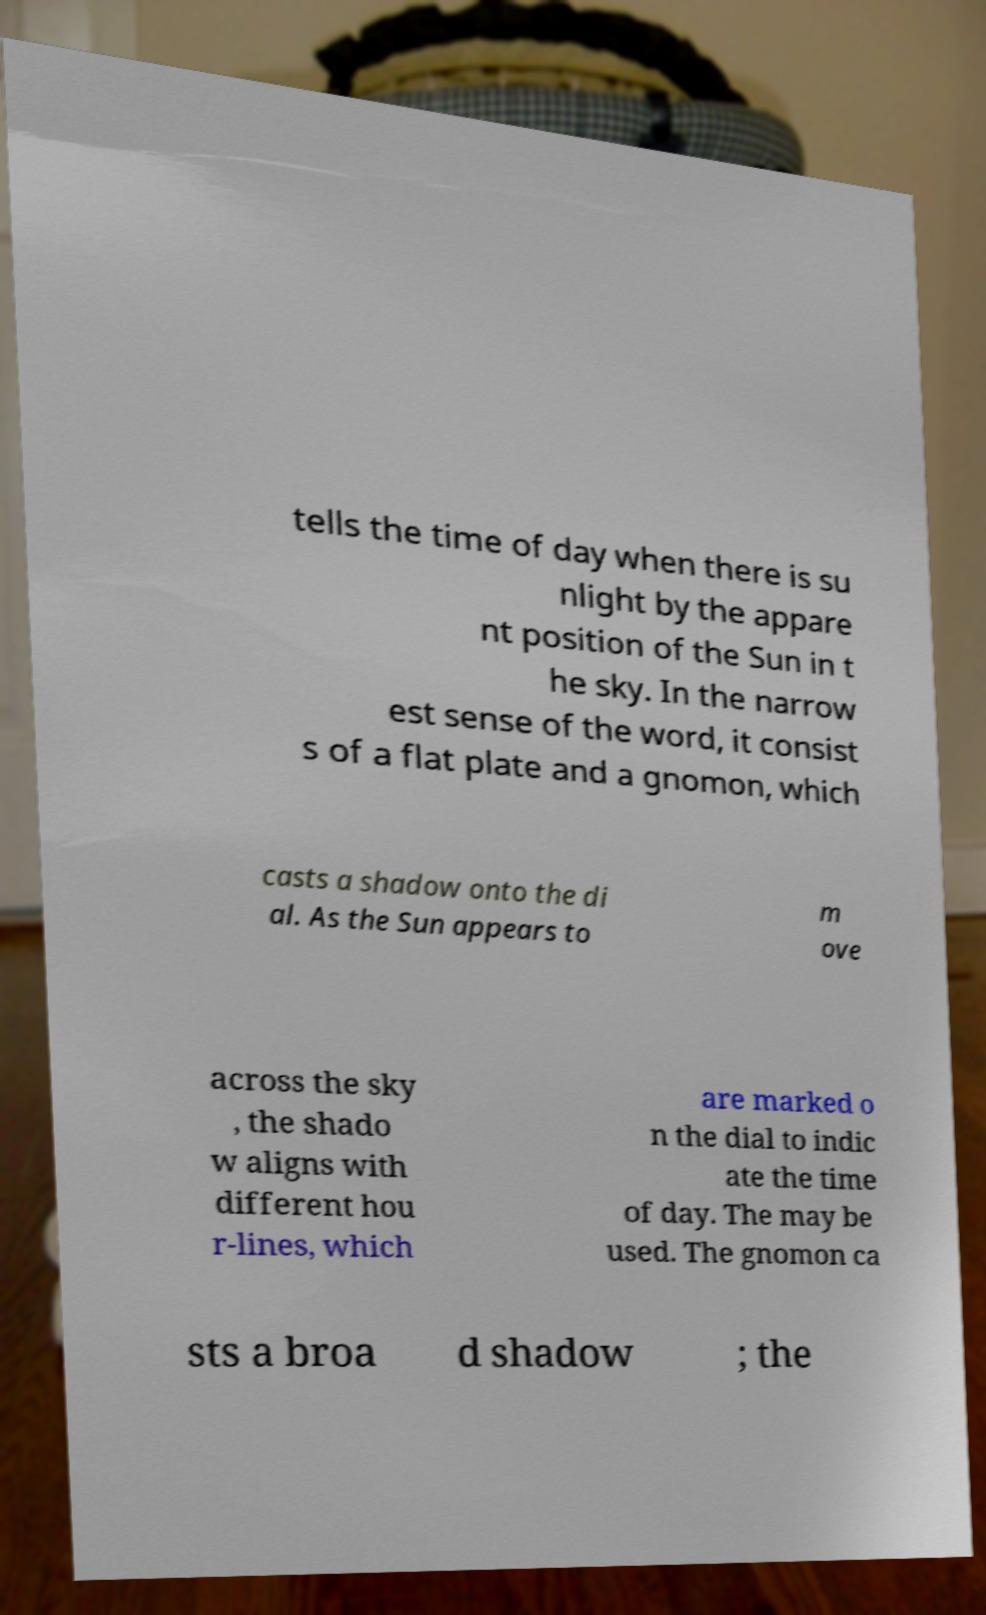What messages or text are displayed in this image? I need them in a readable, typed format. tells the time of day when there is su nlight by the appare nt position of the Sun in t he sky. In the narrow est sense of the word, it consist s of a flat plate and a gnomon, which casts a shadow onto the di al. As the Sun appears to m ove across the sky , the shado w aligns with different hou r-lines, which are marked o n the dial to indic ate the time of day. The may be used. The gnomon ca sts a broa d shadow ; the 